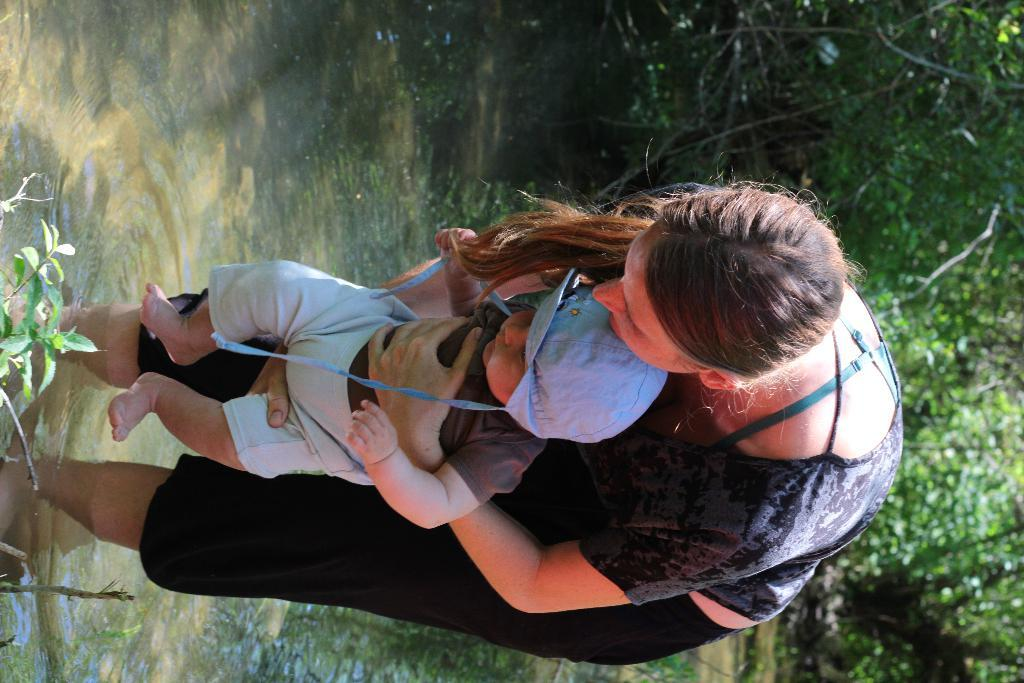What is the woman doing in the water? The woman is standing in the water. Is the woman holding anything while standing in the water? Yes, the woman is carrying a baby. What can be seen on the left side of the image? There are leaves on the left side of the image. What type of vegetation is visible on the right side of the image? There are trees on the right side of the image. What type of necklace is the woman wearing in the image? There is no mention of a necklace in the provided facts, so we cannot determine if the woman is wearing one in the image. Are there any lizards visible in the image? There is no mention of lizards in the provided facts, so we cannot determine if any are present in the image. 